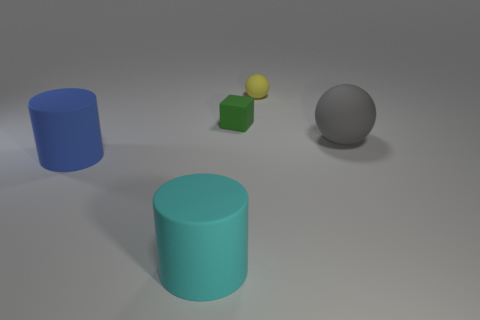Are there an equal number of big cylinders right of the large gray matte ball and big blue rubber objects on the left side of the large blue matte cylinder?
Ensure brevity in your answer.  Yes. What is the material of the ball that is in front of the small rubber ball?
Your response must be concise. Rubber. How many objects are either rubber cylinders behind the big cyan cylinder or small cyan metallic balls?
Make the answer very short. 1. How many other objects are there of the same shape as the green rubber object?
Provide a succinct answer. 0. There is a object that is on the right side of the yellow rubber ball; is it the same shape as the small yellow thing?
Provide a short and direct response. Yes. Are there any small objects on the left side of the yellow thing?
Offer a terse response. Yes. What number of tiny things are blue things or red rubber cylinders?
Keep it short and to the point. 0. There is a cyan thing that is the same material as the big gray ball; what size is it?
Your answer should be compact. Large. What shape is the large thing right of the small object on the left side of the matte sphere that is on the left side of the large rubber sphere?
Offer a terse response. Sphere. What size is the gray rubber thing that is the same shape as the tiny yellow thing?
Keep it short and to the point. Large. 